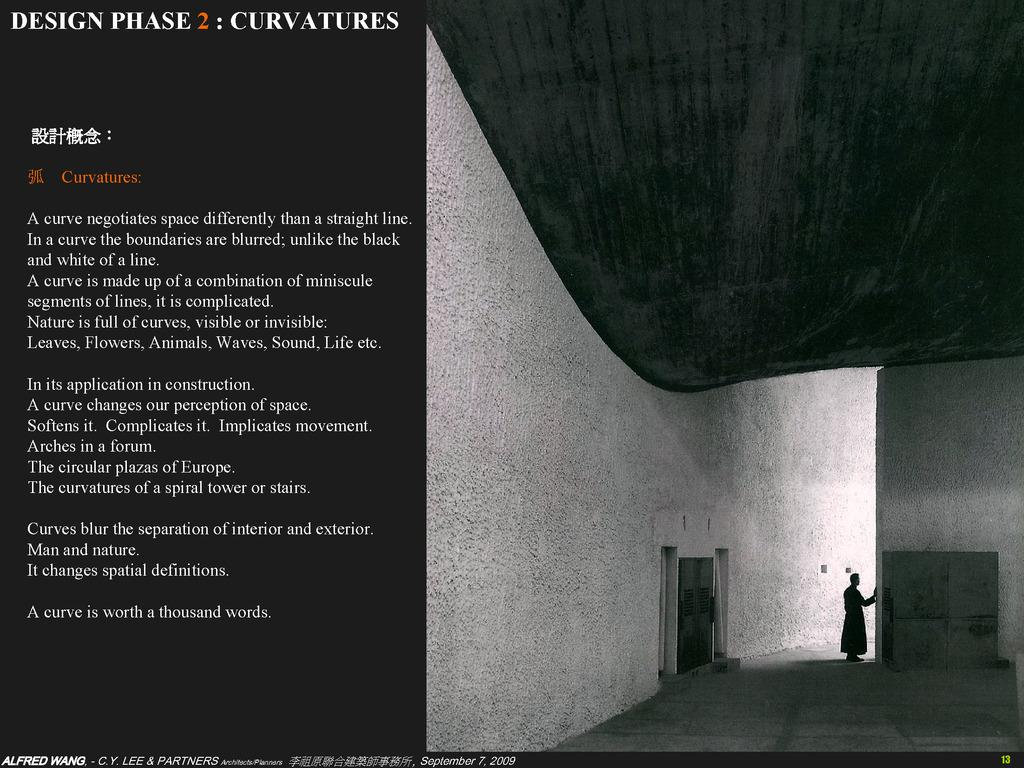What is featured in the image? There is a poster in the image. Can you describe the poster? There is a picture on the right side of the poster, and there is text on the left side of the poster. What is happening in the picture on the poster? In the picture, a person is standing. What else can be seen in the picture? There is a wall in the picture. What type of dinner is being served on the poster? There is no dinner being served on the poster; it features a picture of a person standing with text on the left side. Can you see any ants crawling on the poster? There are no ants present in the image. 